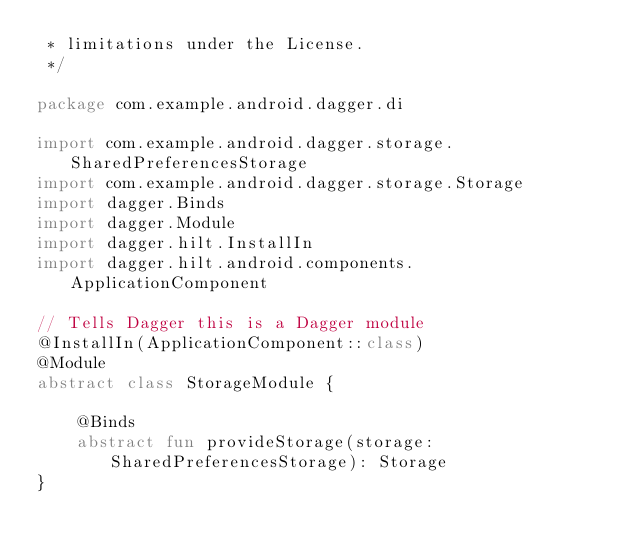<code> <loc_0><loc_0><loc_500><loc_500><_Kotlin_> * limitations under the License.
 */

package com.example.android.dagger.di

import com.example.android.dagger.storage.SharedPreferencesStorage
import com.example.android.dagger.storage.Storage
import dagger.Binds
import dagger.Module
import dagger.hilt.InstallIn
import dagger.hilt.android.components.ApplicationComponent

// Tells Dagger this is a Dagger module
@InstallIn(ApplicationComponent::class)
@Module
abstract class StorageModule {

    @Binds
    abstract fun provideStorage(storage: SharedPreferencesStorage): Storage
}
</code> 